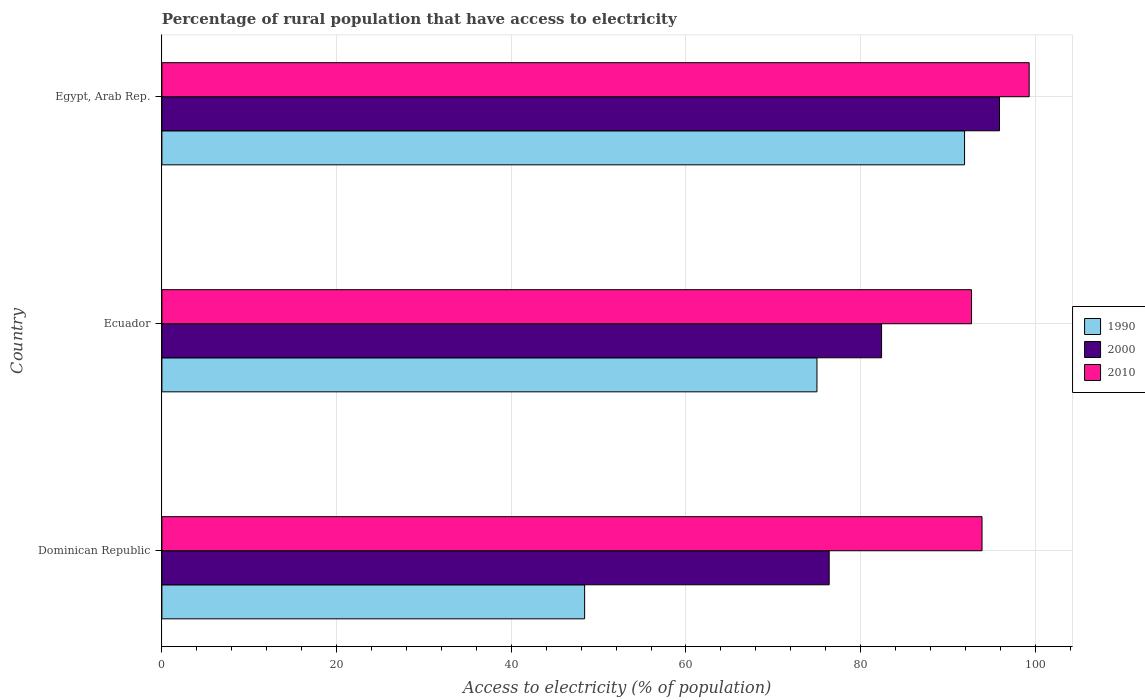How many different coloured bars are there?
Give a very brief answer. 3. Are the number of bars on each tick of the Y-axis equal?
Your answer should be very brief. Yes. How many bars are there on the 2nd tick from the top?
Your answer should be very brief. 3. How many bars are there on the 3rd tick from the bottom?
Your answer should be compact. 3. What is the label of the 1st group of bars from the top?
Your answer should be compact. Egypt, Arab Rep. What is the percentage of rural population that have access to electricity in 2000 in Dominican Republic?
Provide a succinct answer. 76.4. Across all countries, what is the maximum percentage of rural population that have access to electricity in 2000?
Offer a very short reply. 95.9. Across all countries, what is the minimum percentage of rural population that have access to electricity in 2010?
Your answer should be very brief. 92.7. In which country was the percentage of rural population that have access to electricity in 2000 maximum?
Provide a succinct answer. Egypt, Arab Rep. In which country was the percentage of rural population that have access to electricity in 2010 minimum?
Keep it short and to the point. Ecuador. What is the total percentage of rural population that have access to electricity in 2010 in the graph?
Provide a succinct answer. 285.9. What is the difference between the percentage of rural population that have access to electricity in 2010 in Dominican Republic and that in Egypt, Arab Rep.?
Make the answer very short. -5.4. What is the difference between the percentage of rural population that have access to electricity in 1990 in Dominican Republic and the percentage of rural population that have access to electricity in 2000 in Ecuador?
Offer a terse response. -34. What is the average percentage of rural population that have access to electricity in 2010 per country?
Your response must be concise. 95.3. In how many countries, is the percentage of rural population that have access to electricity in 2000 greater than 64 %?
Offer a very short reply. 3. What is the ratio of the percentage of rural population that have access to electricity in 1990 in Ecuador to that in Egypt, Arab Rep.?
Ensure brevity in your answer.  0.82. Is the percentage of rural population that have access to electricity in 2010 in Dominican Republic less than that in Egypt, Arab Rep.?
Keep it short and to the point. Yes. What is the difference between the highest and the second highest percentage of rural population that have access to electricity in 2010?
Provide a succinct answer. 5.4. What is the difference between the highest and the lowest percentage of rural population that have access to electricity in 2000?
Your answer should be compact. 19.5. In how many countries, is the percentage of rural population that have access to electricity in 1990 greater than the average percentage of rural population that have access to electricity in 1990 taken over all countries?
Your response must be concise. 2. What does the 1st bar from the bottom in Dominican Republic represents?
Offer a very short reply. 1990. Is it the case that in every country, the sum of the percentage of rural population that have access to electricity in 2010 and percentage of rural population that have access to electricity in 2000 is greater than the percentage of rural population that have access to electricity in 1990?
Ensure brevity in your answer.  Yes. Are the values on the major ticks of X-axis written in scientific E-notation?
Keep it short and to the point. No. Does the graph contain any zero values?
Your response must be concise. No. Does the graph contain grids?
Make the answer very short. Yes. How are the legend labels stacked?
Make the answer very short. Vertical. What is the title of the graph?
Make the answer very short. Percentage of rural population that have access to electricity. Does "2004" appear as one of the legend labels in the graph?
Keep it short and to the point. No. What is the label or title of the X-axis?
Ensure brevity in your answer.  Access to electricity (% of population). What is the label or title of the Y-axis?
Provide a succinct answer. Country. What is the Access to electricity (% of population) in 1990 in Dominican Republic?
Give a very brief answer. 48.4. What is the Access to electricity (% of population) in 2000 in Dominican Republic?
Provide a succinct answer. 76.4. What is the Access to electricity (% of population) of 2010 in Dominican Republic?
Give a very brief answer. 93.9. What is the Access to electricity (% of population) of 1990 in Ecuador?
Keep it short and to the point. 75. What is the Access to electricity (% of population) of 2000 in Ecuador?
Your answer should be compact. 82.4. What is the Access to electricity (% of population) of 2010 in Ecuador?
Make the answer very short. 92.7. What is the Access to electricity (% of population) in 1990 in Egypt, Arab Rep.?
Keep it short and to the point. 91.9. What is the Access to electricity (% of population) of 2000 in Egypt, Arab Rep.?
Give a very brief answer. 95.9. What is the Access to electricity (% of population) of 2010 in Egypt, Arab Rep.?
Your answer should be compact. 99.3. Across all countries, what is the maximum Access to electricity (% of population) of 1990?
Your response must be concise. 91.9. Across all countries, what is the maximum Access to electricity (% of population) in 2000?
Offer a very short reply. 95.9. Across all countries, what is the maximum Access to electricity (% of population) of 2010?
Offer a terse response. 99.3. Across all countries, what is the minimum Access to electricity (% of population) of 1990?
Your answer should be very brief. 48.4. Across all countries, what is the minimum Access to electricity (% of population) of 2000?
Your answer should be compact. 76.4. Across all countries, what is the minimum Access to electricity (% of population) in 2010?
Your answer should be very brief. 92.7. What is the total Access to electricity (% of population) in 1990 in the graph?
Your answer should be very brief. 215.3. What is the total Access to electricity (% of population) in 2000 in the graph?
Offer a very short reply. 254.7. What is the total Access to electricity (% of population) of 2010 in the graph?
Ensure brevity in your answer.  285.9. What is the difference between the Access to electricity (% of population) in 1990 in Dominican Republic and that in Ecuador?
Give a very brief answer. -26.6. What is the difference between the Access to electricity (% of population) in 2000 in Dominican Republic and that in Ecuador?
Offer a terse response. -6. What is the difference between the Access to electricity (% of population) of 2010 in Dominican Republic and that in Ecuador?
Provide a succinct answer. 1.2. What is the difference between the Access to electricity (% of population) of 1990 in Dominican Republic and that in Egypt, Arab Rep.?
Your response must be concise. -43.5. What is the difference between the Access to electricity (% of population) of 2000 in Dominican Republic and that in Egypt, Arab Rep.?
Offer a terse response. -19.5. What is the difference between the Access to electricity (% of population) in 1990 in Ecuador and that in Egypt, Arab Rep.?
Make the answer very short. -16.9. What is the difference between the Access to electricity (% of population) of 2000 in Ecuador and that in Egypt, Arab Rep.?
Your response must be concise. -13.5. What is the difference between the Access to electricity (% of population) in 1990 in Dominican Republic and the Access to electricity (% of population) in 2000 in Ecuador?
Give a very brief answer. -34. What is the difference between the Access to electricity (% of population) in 1990 in Dominican Republic and the Access to electricity (% of population) in 2010 in Ecuador?
Make the answer very short. -44.3. What is the difference between the Access to electricity (% of population) in 2000 in Dominican Republic and the Access to electricity (% of population) in 2010 in Ecuador?
Make the answer very short. -16.3. What is the difference between the Access to electricity (% of population) in 1990 in Dominican Republic and the Access to electricity (% of population) in 2000 in Egypt, Arab Rep.?
Provide a short and direct response. -47.5. What is the difference between the Access to electricity (% of population) of 1990 in Dominican Republic and the Access to electricity (% of population) of 2010 in Egypt, Arab Rep.?
Give a very brief answer. -50.9. What is the difference between the Access to electricity (% of population) in 2000 in Dominican Republic and the Access to electricity (% of population) in 2010 in Egypt, Arab Rep.?
Provide a short and direct response. -22.9. What is the difference between the Access to electricity (% of population) of 1990 in Ecuador and the Access to electricity (% of population) of 2000 in Egypt, Arab Rep.?
Offer a very short reply. -20.9. What is the difference between the Access to electricity (% of population) in 1990 in Ecuador and the Access to electricity (% of population) in 2010 in Egypt, Arab Rep.?
Your answer should be very brief. -24.3. What is the difference between the Access to electricity (% of population) in 2000 in Ecuador and the Access to electricity (% of population) in 2010 in Egypt, Arab Rep.?
Your response must be concise. -16.9. What is the average Access to electricity (% of population) of 1990 per country?
Give a very brief answer. 71.77. What is the average Access to electricity (% of population) in 2000 per country?
Offer a very short reply. 84.9. What is the average Access to electricity (% of population) of 2010 per country?
Your answer should be compact. 95.3. What is the difference between the Access to electricity (% of population) in 1990 and Access to electricity (% of population) in 2000 in Dominican Republic?
Give a very brief answer. -28. What is the difference between the Access to electricity (% of population) in 1990 and Access to electricity (% of population) in 2010 in Dominican Republic?
Ensure brevity in your answer.  -45.5. What is the difference between the Access to electricity (% of population) in 2000 and Access to electricity (% of population) in 2010 in Dominican Republic?
Provide a succinct answer. -17.5. What is the difference between the Access to electricity (% of population) in 1990 and Access to electricity (% of population) in 2010 in Ecuador?
Provide a short and direct response. -17.7. What is the difference between the Access to electricity (% of population) of 2000 and Access to electricity (% of population) of 2010 in Ecuador?
Give a very brief answer. -10.3. What is the difference between the Access to electricity (% of population) in 1990 and Access to electricity (% of population) in 2000 in Egypt, Arab Rep.?
Keep it short and to the point. -4. What is the difference between the Access to electricity (% of population) in 1990 and Access to electricity (% of population) in 2010 in Egypt, Arab Rep.?
Keep it short and to the point. -7.4. What is the ratio of the Access to electricity (% of population) in 1990 in Dominican Republic to that in Ecuador?
Give a very brief answer. 0.65. What is the ratio of the Access to electricity (% of population) in 2000 in Dominican Republic to that in Ecuador?
Give a very brief answer. 0.93. What is the ratio of the Access to electricity (% of population) in 2010 in Dominican Republic to that in Ecuador?
Ensure brevity in your answer.  1.01. What is the ratio of the Access to electricity (% of population) in 1990 in Dominican Republic to that in Egypt, Arab Rep.?
Ensure brevity in your answer.  0.53. What is the ratio of the Access to electricity (% of population) of 2000 in Dominican Republic to that in Egypt, Arab Rep.?
Offer a very short reply. 0.8. What is the ratio of the Access to electricity (% of population) in 2010 in Dominican Republic to that in Egypt, Arab Rep.?
Your answer should be very brief. 0.95. What is the ratio of the Access to electricity (% of population) in 1990 in Ecuador to that in Egypt, Arab Rep.?
Offer a very short reply. 0.82. What is the ratio of the Access to electricity (% of population) of 2000 in Ecuador to that in Egypt, Arab Rep.?
Offer a terse response. 0.86. What is the ratio of the Access to electricity (% of population) in 2010 in Ecuador to that in Egypt, Arab Rep.?
Provide a succinct answer. 0.93. What is the difference between the highest and the second highest Access to electricity (% of population) in 2000?
Offer a very short reply. 13.5. What is the difference between the highest and the second highest Access to electricity (% of population) in 2010?
Offer a very short reply. 5.4. What is the difference between the highest and the lowest Access to electricity (% of population) of 1990?
Provide a succinct answer. 43.5. What is the difference between the highest and the lowest Access to electricity (% of population) in 2010?
Provide a short and direct response. 6.6. 